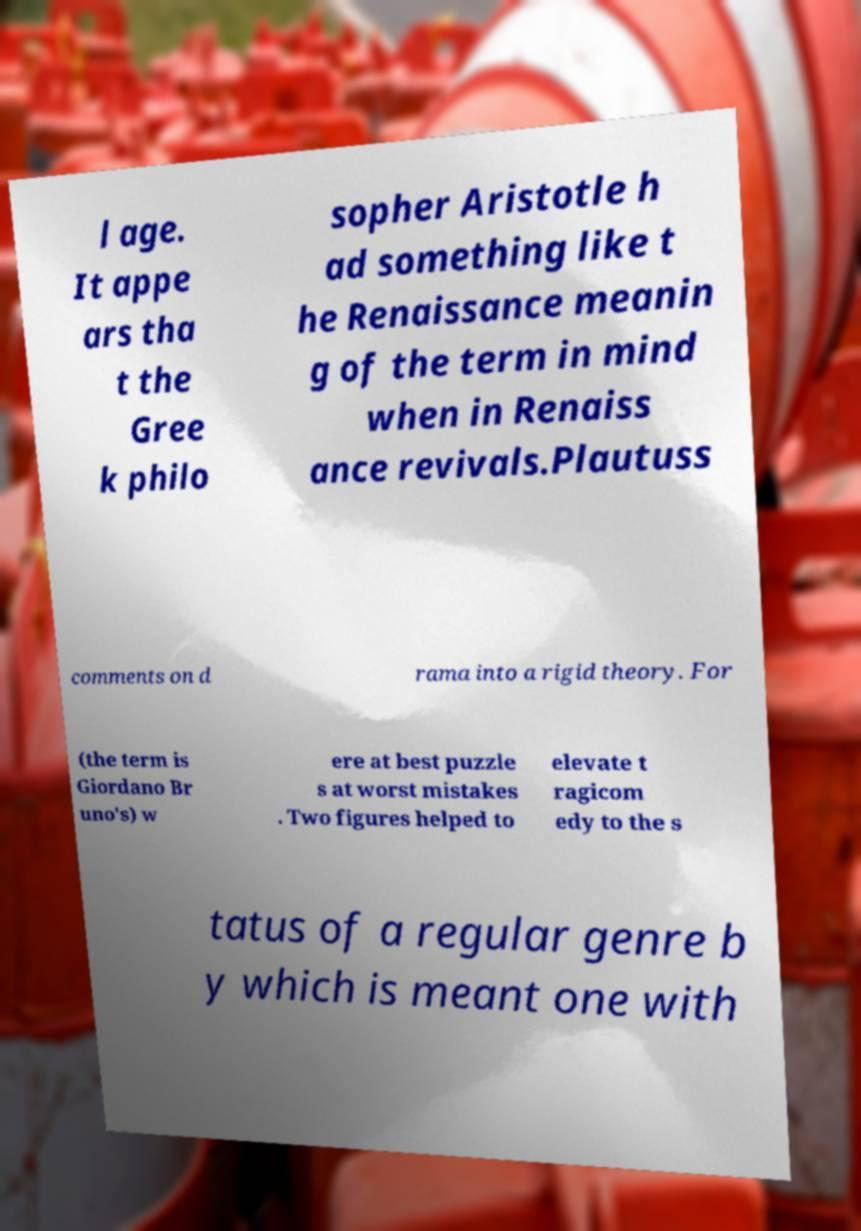I need the written content from this picture converted into text. Can you do that? l age. It appe ars tha t the Gree k philo sopher Aristotle h ad something like t he Renaissance meanin g of the term in mind when in Renaiss ance revivals.Plautuss comments on d rama into a rigid theory. For (the term is Giordano Br uno's) w ere at best puzzle s at worst mistakes . Two figures helped to elevate t ragicom edy to the s tatus of a regular genre b y which is meant one with 